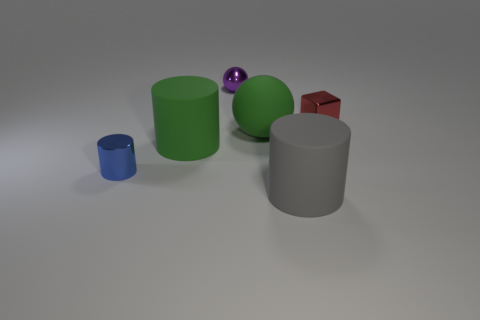What number of other objects are there of the same color as the large matte ball?
Make the answer very short. 1. What size is the other object that is the same shape as the purple object?
Your response must be concise. Large. Are there the same number of green rubber objects to the right of the red shiny thing and tiny objects to the right of the green cylinder?
Provide a short and direct response. No. What number of small brown matte spheres are there?
Provide a succinct answer. 0. Is the number of big cylinders in front of the small red block greater than the number of large rubber spheres?
Give a very brief answer. Yes. There is a big cylinder that is behind the small blue shiny cylinder; what material is it?
Your response must be concise. Rubber. The other object that is the same shape as the purple metallic thing is what color?
Offer a terse response. Green. How many large cylinders have the same color as the big matte ball?
Your answer should be compact. 1. There is a matte cylinder behind the large gray rubber cylinder; is its size the same as the metal object that is on the right side of the tiny purple sphere?
Keep it short and to the point. No. Do the metallic cube and the metallic thing on the left side of the purple shiny sphere have the same size?
Offer a terse response. Yes. 